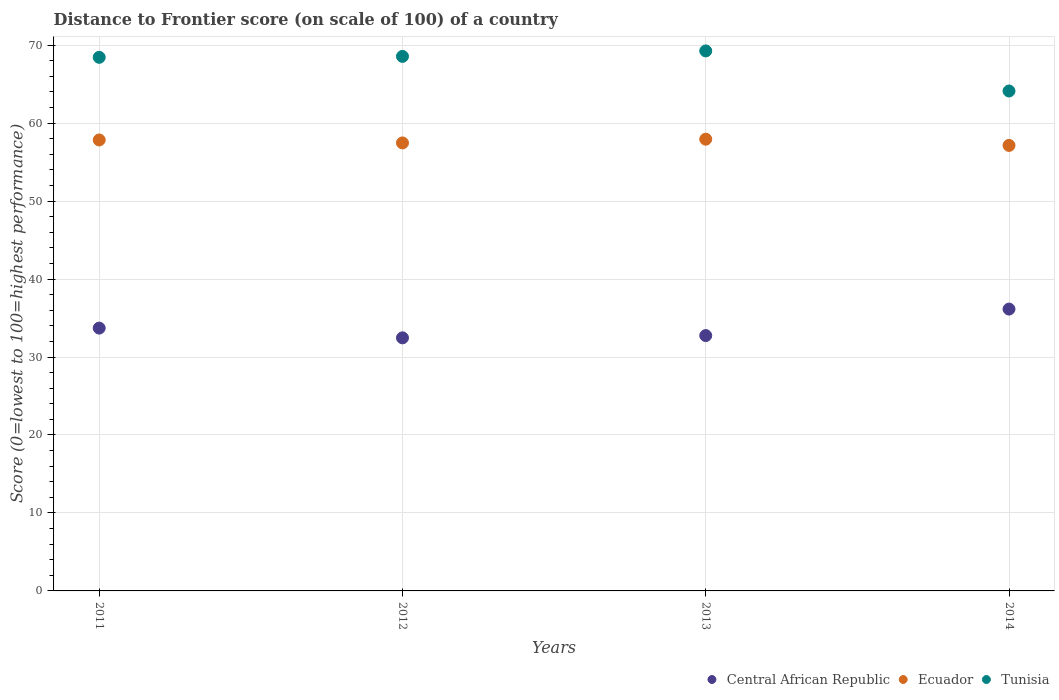How many different coloured dotlines are there?
Ensure brevity in your answer.  3. What is the distance to frontier score of in Ecuador in 2013?
Your response must be concise. 57.94. Across all years, what is the maximum distance to frontier score of in Central African Republic?
Your response must be concise. 36.15. Across all years, what is the minimum distance to frontier score of in Ecuador?
Offer a very short reply. 57.14. In which year was the distance to frontier score of in Tunisia maximum?
Ensure brevity in your answer.  2013. In which year was the distance to frontier score of in Central African Republic minimum?
Offer a terse response. 2012. What is the total distance to frontier score of in Ecuador in the graph?
Keep it short and to the point. 230.38. What is the difference between the distance to frontier score of in Ecuador in 2011 and that in 2014?
Your answer should be very brief. 0.7. What is the difference between the distance to frontier score of in Ecuador in 2011 and the distance to frontier score of in Tunisia in 2014?
Provide a short and direct response. -6.28. What is the average distance to frontier score of in Tunisia per year?
Keep it short and to the point. 67.59. In the year 2014, what is the difference between the distance to frontier score of in Central African Republic and distance to frontier score of in Tunisia?
Offer a terse response. -27.97. What is the ratio of the distance to frontier score of in Ecuador in 2011 to that in 2014?
Give a very brief answer. 1.01. Is the distance to frontier score of in Ecuador in 2011 less than that in 2012?
Offer a very short reply. No. Is the difference between the distance to frontier score of in Central African Republic in 2013 and 2014 greater than the difference between the distance to frontier score of in Tunisia in 2013 and 2014?
Provide a succinct answer. No. What is the difference between the highest and the second highest distance to frontier score of in Tunisia?
Your answer should be very brief. 0.7. What is the difference between the highest and the lowest distance to frontier score of in Ecuador?
Make the answer very short. 0.8. Does the distance to frontier score of in Tunisia monotonically increase over the years?
Your response must be concise. No. How many dotlines are there?
Your response must be concise. 3. How many years are there in the graph?
Provide a short and direct response. 4. What is the difference between two consecutive major ticks on the Y-axis?
Your answer should be very brief. 10. Are the values on the major ticks of Y-axis written in scientific E-notation?
Give a very brief answer. No. Does the graph contain grids?
Offer a very short reply. Yes. How many legend labels are there?
Make the answer very short. 3. What is the title of the graph?
Offer a very short reply. Distance to Frontier score (on scale of 100) of a country. Does "Spain" appear as one of the legend labels in the graph?
Make the answer very short. No. What is the label or title of the Y-axis?
Offer a very short reply. Score (0=lowest to 100=highest performance). What is the Score (0=lowest to 100=highest performance) of Central African Republic in 2011?
Give a very brief answer. 33.71. What is the Score (0=lowest to 100=highest performance) of Ecuador in 2011?
Make the answer very short. 57.84. What is the Score (0=lowest to 100=highest performance) in Tunisia in 2011?
Your response must be concise. 68.44. What is the Score (0=lowest to 100=highest performance) of Central African Republic in 2012?
Ensure brevity in your answer.  32.46. What is the Score (0=lowest to 100=highest performance) in Ecuador in 2012?
Offer a very short reply. 57.46. What is the Score (0=lowest to 100=highest performance) in Tunisia in 2012?
Keep it short and to the point. 68.56. What is the Score (0=lowest to 100=highest performance) in Central African Republic in 2013?
Give a very brief answer. 32.75. What is the Score (0=lowest to 100=highest performance) of Ecuador in 2013?
Provide a short and direct response. 57.94. What is the Score (0=lowest to 100=highest performance) of Tunisia in 2013?
Your response must be concise. 69.26. What is the Score (0=lowest to 100=highest performance) of Central African Republic in 2014?
Your answer should be very brief. 36.15. What is the Score (0=lowest to 100=highest performance) in Ecuador in 2014?
Offer a terse response. 57.14. What is the Score (0=lowest to 100=highest performance) of Tunisia in 2014?
Ensure brevity in your answer.  64.12. Across all years, what is the maximum Score (0=lowest to 100=highest performance) in Central African Republic?
Ensure brevity in your answer.  36.15. Across all years, what is the maximum Score (0=lowest to 100=highest performance) of Ecuador?
Make the answer very short. 57.94. Across all years, what is the maximum Score (0=lowest to 100=highest performance) in Tunisia?
Offer a very short reply. 69.26. Across all years, what is the minimum Score (0=lowest to 100=highest performance) of Central African Republic?
Your answer should be very brief. 32.46. Across all years, what is the minimum Score (0=lowest to 100=highest performance) of Ecuador?
Give a very brief answer. 57.14. Across all years, what is the minimum Score (0=lowest to 100=highest performance) of Tunisia?
Keep it short and to the point. 64.12. What is the total Score (0=lowest to 100=highest performance) of Central African Republic in the graph?
Your answer should be compact. 135.07. What is the total Score (0=lowest to 100=highest performance) in Ecuador in the graph?
Provide a succinct answer. 230.38. What is the total Score (0=lowest to 100=highest performance) in Tunisia in the graph?
Your answer should be compact. 270.38. What is the difference between the Score (0=lowest to 100=highest performance) in Ecuador in 2011 and that in 2012?
Provide a short and direct response. 0.38. What is the difference between the Score (0=lowest to 100=highest performance) of Tunisia in 2011 and that in 2012?
Offer a terse response. -0.12. What is the difference between the Score (0=lowest to 100=highest performance) of Central African Republic in 2011 and that in 2013?
Make the answer very short. 0.96. What is the difference between the Score (0=lowest to 100=highest performance) in Tunisia in 2011 and that in 2013?
Offer a very short reply. -0.82. What is the difference between the Score (0=lowest to 100=highest performance) of Central African Republic in 2011 and that in 2014?
Keep it short and to the point. -2.44. What is the difference between the Score (0=lowest to 100=highest performance) of Ecuador in 2011 and that in 2014?
Your answer should be very brief. 0.7. What is the difference between the Score (0=lowest to 100=highest performance) of Tunisia in 2011 and that in 2014?
Provide a succinct answer. 4.32. What is the difference between the Score (0=lowest to 100=highest performance) in Central African Republic in 2012 and that in 2013?
Your answer should be very brief. -0.29. What is the difference between the Score (0=lowest to 100=highest performance) of Ecuador in 2012 and that in 2013?
Ensure brevity in your answer.  -0.48. What is the difference between the Score (0=lowest to 100=highest performance) of Central African Republic in 2012 and that in 2014?
Keep it short and to the point. -3.69. What is the difference between the Score (0=lowest to 100=highest performance) in Ecuador in 2012 and that in 2014?
Make the answer very short. 0.32. What is the difference between the Score (0=lowest to 100=highest performance) in Tunisia in 2012 and that in 2014?
Keep it short and to the point. 4.44. What is the difference between the Score (0=lowest to 100=highest performance) of Central African Republic in 2013 and that in 2014?
Offer a terse response. -3.4. What is the difference between the Score (0=lowest to 100=highest performance) of Tunisia in 2013 and that in 2014?
Offer a terse response. 5.14. What is the difference between the Score (0=lowest to 100=highest performance) in Central African Republic in 2011 and the Score (0=lowest to 100=highest performance) in Ecuador in 2012?
Your answer should be compact. -23.75. What is the difference between the Score (0=lowest to 100=highest performance) of Central African Republic in 2011 and the Score (0=lowest to 100=highest performance) of Tunisia in 2012?
Provide a short and direct response. -34.85. What is the difference between the Score (0=lowest to 100=highest performance) of Ecuador in 2011 and the Score (0=lowest to 100=highest performance) of Tunisia in 2012?
Give a very brief answer. -10.72. What is the difference between the Score (0=lowest to 100=highest performance) of Central African Republic in 2011 and the Score (0=lowest to 100=highest performance) of Ecuador in 2013?
Offer a terse response. -24.23. What is the difference between the Score (0=lowest to 100=highest performance) of Central African Republic in 2011 and the Score (0=lowest to 100=highest performance) of Tunisia in 2013?
Your answer should be very brief. -35.55. What is the difference between the Score (0=lowest to 100=highest performance) in Ecuador in 2011 and the Score (0=lowest to 100=highest performance) in Tunisia in 2013?
Make the answer very short. -11.42. What is the difference between the Score (0=lowest to 100=highest performance) in Central African Republic in 2011 and the Score (0=lowest to 100=highest performance) in Ecuador in 2014?
Offer a terse response. -23.43. What is the difference between the Score (0=lowest to 100=highest performance) in Central African Republic in 2011 and the Score (0=lowest to 100=highest performance) in Tunisia in 2014?
Provide a succinct answer. -30.41. What is the difference between the Score (0=lowest to 100=highest performance) in Ecuador in 2011 and the Score (0=lowest to 100=highest performance) in Tunisia in 2014?
Your answer should be compact. -6.28. What is the difference between the Score (0=lowest to 100=highest performance) in Central African Republic in 2012 and the Score (0=lowest to 100=highest performance) in Ecuador in 2013?
Keep it short and to the point. -25.48. What is the difference between the Score (0=lowest to 100=highest performance) of Central African Republic in 2012 and the Score (0=lowest to 100=highest performance) of Tunisia in 2013?
Your answer should be very brief. -36.8. What is the difference between the Score (0=lowest to 100=highest performance) of Ecuador in 2012 and the Score (0=lowest to 100=highest performance) of Tunisia in 2013?
Your response must be concise. -11.8. What is the difference between the Score (0=lowest to 100=highest performance) in Central African Republic in 2012 and the Score (0=lowest to 100=highest performance) in Ecuador in 2014?
Provide a short and direct response. -24.68. What is the difference between the Score (0=lowest to 100=highest performance) of Central African Republic in 2012 and the Score (0=lowest to 100=highest performance) of Tunisia in 2014?
Your answer should be compact. -31.66. What is the difference between the Score (0=lowest to 100=highest performance) of Ecuador in 2012 and the Score (0=lowest to 100=highest performance) of Tunisia in 2014?
Provide a short and direct response. -6.66. What is the difference between the Score (0=lowest to 100=highest performance) in Central African Republic in 2013 and the Score (0=lowest to 100=highest performance) in Ecuador in 2014?
Your answer should be very brief. -24.39. What is the difference between the Score (0=lowest to 100=highest performance) in Central African Republic in 2013 and the Score (0=lowest to 100=highest performance) in Tunisia in 2014?
Provide a succinct answer. -31.37. What is the difference between the Score (0=lowest to 100=highest performance) in Ecuador in 2013 and the Score (0=lowest to 100=highest performance) in Tunisia in 2014?
Your answer should be compact. -6.18. What is the average Score (0=lowest to 100=highest performance) of Central African Republic per year?
Offer a terse response. 33.77. What is the average Score (0=lowest to 100=highest performance) of Ecuador per year?
Keep it short and to the point. 57.59. What is the average Score (0=lowest to 100=highest performance) in Tunisia per year?
Offer a very short reply. 67.59. In the year 2011, what is the difference between the Score (0=lowest to 100=highest performance) in Central African Republic and Score (0=lowest to 100=highest performance) in Ecuador?
Provide a short and direct response. -24.13. In the year 2011, what is the difference between the Score (0=lowest to 100=highest performance) of Central African Republic and Score (0=lowest to 100=highest performance) of Tunisia?
Offer a very short reply. -34.73. In the year 2011, what is the difference between the Score (0=lowest to 100=highest performance) in Ecuador and Score (0=lowest to 100=highest performance) in Tunisia?
Your answer should be very brief. -10.6. In the year 2012, what is the difference between the Score (0=lowest to 100=highest performance) in Central African Republic and Score (0=lowest to 100=highest performance) in Tunisia?
Keep it short and to the point. -36.1. In the year 2013, what is the difference between the Score (0=lowest to 100=highest performance) of Central African Republic and Score (0=lowest to 100=highest performance) of Ecuador?
Keep it short and to the point. -25.19. In the year 2013, what is the difference between the Score (0=lowest to 100=highest performance) of Central African Republic and Score (0=lowest to 100=highest performance) of Tunisia?
Keep it short and to the point. -36.51. In the year 2013, what is the difference between the Score (0=lowest to 100=highest performance) in Ecuador and Score (0=lowest to 100=highest performance) in Tunisia?
Keep it short and to the point. -11.32. In the year 2014, what is the difference between the Score (0=lowest to 100=highest performance) in Central African Republic and Score (0=lowest to 100=highest performance) in Ecuador?
Your answer should be very brief. -20.99. In the year 2014, what is the difference between the Score (0=lowest to 100=highest performance) in Central African Republic and Score (0=lowest to 100=highest performance) in Tunisia?
Provide a succinct answer. -27.97. In the year 2014, what is the difference between the Score (0=lowest to 100=highest performance) in Ecuador and Score (0=lowest to 100=highest performance) in Tunisia?
Provide a succinct answer. -6.98. What is the ratio of the Score (0=lowest to 100=highest performance) in Central African Republic in 2011 to that in 2012?
Your answer should be very brief. 1.04. What is the ratio of the Score (0=lowest to 100=highest performance) of Ecuador in 2011 to that in 2012?
Your answer should be very brief. 1.01. What is the ratio of the Score (0=lowest to 100=highest performance) in Tunisia in 2011 to that in 2012?
Your answer should be compact. 1. What is the ratio of the Score (0=lowest to 100=highest performance) in Central African Republic in 2011 to that in 2013?
Your answer should be very brief. 1.03. What is the ratio of the Score (0=lowest to 100=highest performance) in Ecuador in 2011 to that in 2013?
Make the answer very short. 1. What is the ratio of the Score (0=lowest to 100=highest performance) in Tunisia in 2011 to that in 2013?
Provide a short and direct response. 0.99. What is the ratio of the Score (0=lowest to 100=highest performance) of Central African Republic in 2011 to that in 2014?
Keep it short and to the point. 0.93. What is the ratio of the Score (0=lowest to 100=highest performance) in Ecuador in 2011 to that in 2014?
Offer a terse response. 1.01. What is the ratio of the Score (0=lowest to 100=highest performance) in Tunisia in 2011 to that in 2014?
Your answer should be compact. 1.07. What is the ratio of the Score (0=lowest to 100=highest performance) of Central African Republic in 2012 to that in 2013?
Your response must be concise. 0.99. What is the ratio of the Score (0=lowest to 100=highest performance) in Ecuador in 2012 to that in 2013?
Offer a terse response. 0.99. What is the ratio of the Score (0=lowest to 100=highest performance) in Central African Republic in 2012 to that in 2014?
Provide a short and direct response. 0.9. What is the ratio of the Score (0=lowest to 100=highest performance) in Ecuador in 2012 to that in 2014?
Provide a short and direct response. 1.01. What is the ratio of the Score (0=lowest to 100=highest performance) in Tunisia in 2012 to that in 2014?
Provide a succinct answer. 1.07. What is the ratio of the Score (0=lowest to 100=highest performance) of Central African Republic in 2013 to that in 2014?
Provide a short and direct response. 0.91. What is the ratio of the Score (0=lowest to 100=highest performance) in Ecuador in 2013 to that in 2014?
Your response must be concise. 1.01. What is the ratio of the Score (0=lowest to 100=highest performance) of Tunisia in 2013 to that in 2014?
Your answer should be very brief. 1.08. What is the difference between the highest and the second highest Score (0=lowest to 100=highest performance) of Central African Republic?
Offer a terse response. 2.44. What is the difference between the highest and the second highest Score (0=lowest to 100=highest performance) in Tunisia?
Give a very brief answer. 0.7. What is the difference between the highest and the lowest Score (0=lowest to 100=highest performance) of Central African Republic?
Ensure brevity in your answer.  3.69. What is the difference between the highest and the lowest Score (0=lowest to 100=highest performance) of Tunisia?
Offer a terse response. 5.14. 